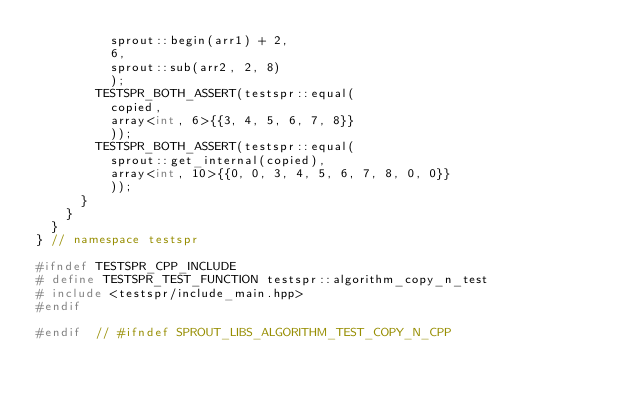<code> <loc_0><loc_0><loc_500><loc_500><_C++_>					sprout::begin(arr1) + 2,
					6,
					sprout::sub(arr2, 2, 8)
					);
				TESTSPR_BOTH_ASSERT(testspr::equal(
					copied,
					array<int, 6>{{3, 4, 5, 6, 7, 8}}
					));
				TESTSPR_BOTH_ASSERT(testspr::equal(
					sprout::get_internal(copied),
					array<int, 10>{{0, 0, 3, 4, 5, 6, 7, 8, 0, 0}}
					));
			}
		}
	}
}	// namespace testspr

#ifndef TESTSPR_CPP_INCLUDE
#	define TESTSPR_TEST_FUNCTION testspr::algorithm_copy_n_test
#	include <testspr/include_main.hpp>
#endif

#endif	// #ifndef SPROUT_LIBS_ALGORITHM_TEST_COPY_N_CPP
</code> 